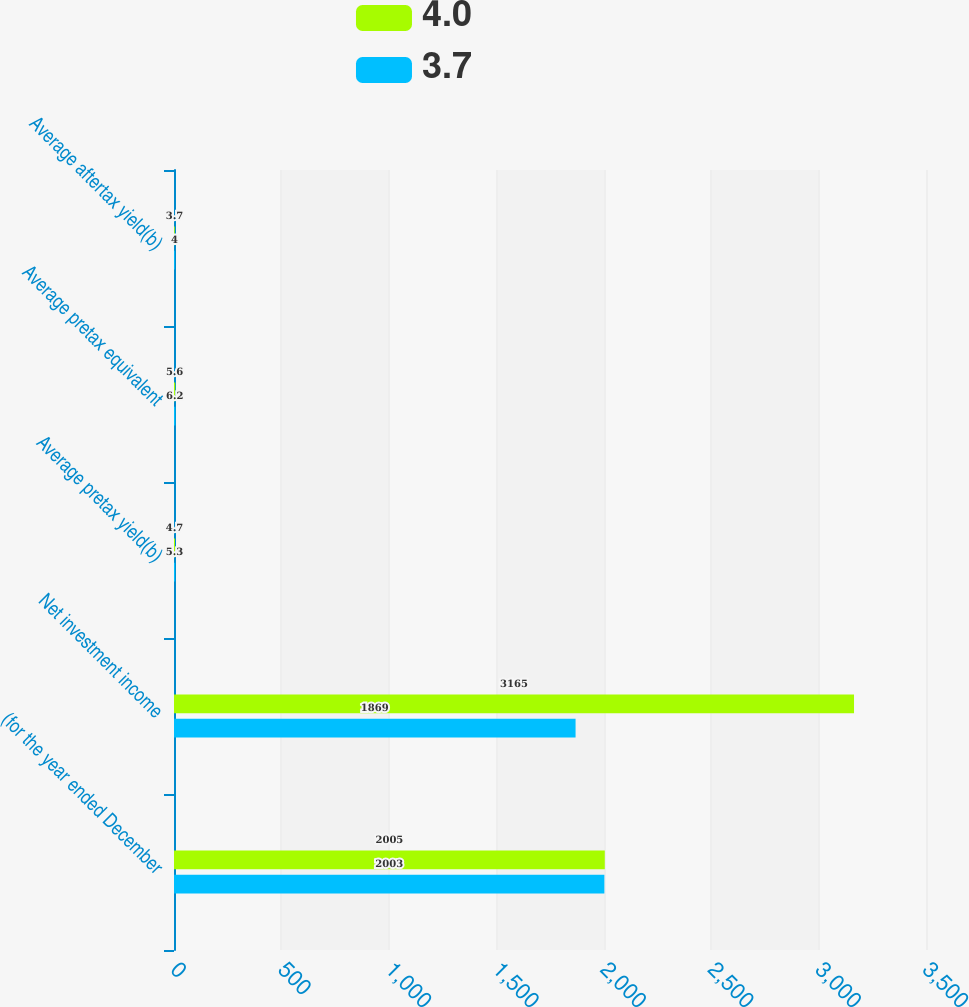Convert chart. <chart><loc_0><loc_0><loc_500><loc_500><stacked_bar_chart><ecel><fcel>(for the year ended December<fcel>Net investment income<fcel>Average pretax yield(b)<fcel>Average pretax equivalent<fcel>Average aftertax yield(b)<nl><fcel>4<fcel>2005<fcel>3165<fcel>4.7<fcel>5.6<fcel>3.7<nl><fcel>3.7<fcel>2003<fcel>1869<fcel>5.3<fcel>6.2<fcel>4<nl></chart> 